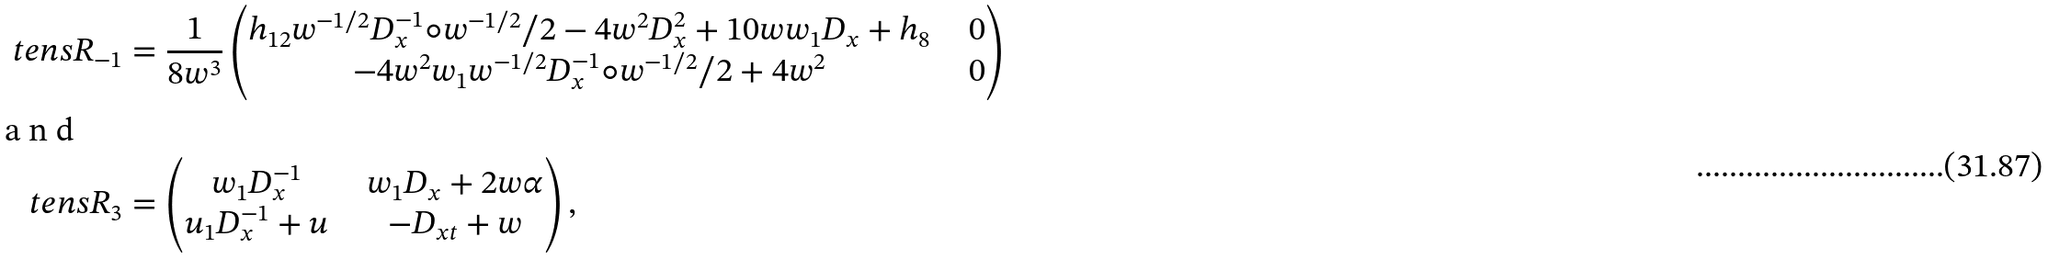Convert formula to latex. <formula><loc_0><loc_0><loc_500><loc_500>\ t e n s { R } _ { - 1 } & = \frac { 1 } { 8 w ^ { 3 } } \begin{pmatrix} h _ { 1 2 } w ^ { - 1 / 2 } D _ { x } ^ { - 1 } \circ w ^ { - 1 / 2 } / 2 - 4 w ^ { 2 } D _ { x } ^ { 2 } + 1 0 w w _ { 1 } D _ { x } + h _ { 8 } & \ & 0 \\ - 4 w ^ { 2 } w _ { 1 } w ^ { - 1 / 2 } D _ { x } ^ { - 1 } \circ w ^ { - 1 / 2 } / 2 + 4 w ^ { 2 } & \ & 0 \end{pmatrix} \intertext { a n d } \ t e n s { R } _ { 3 } & = \begin{pmatrix} w _ { 1 } D _ { x } ^ { - 1 } & \ & w _ { 1 } D _ { x } + 2 w \alpha \\ u _ { 1 } D _ { x } ^ { - 1 } + u & \ & - D _ { x t } + w \\ \end{pmatrix} ,</formula> 